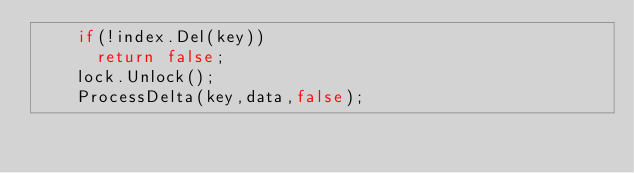Convert code to text. <code><loc_0><loc_0><loc_500><loc_500><_C++_>    if(!index.Del(key))
      return false;
    lock.Unlock();
    ProcessDelta(key,data,false);</code> 